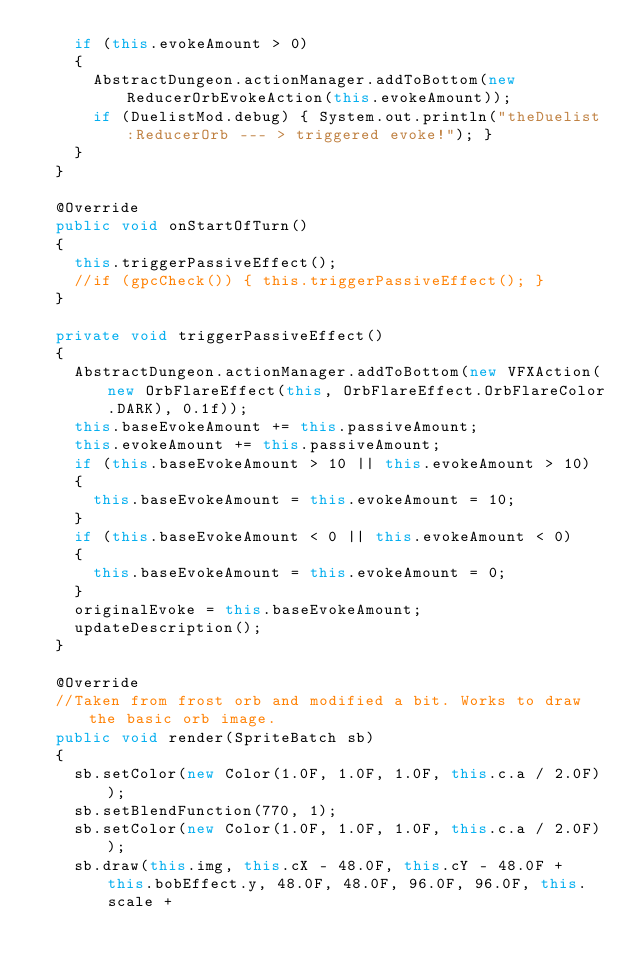Convert code to text. <code><loc_0><loc_0><loc_500><loc_500><_Java_>		if (this.evokeAmount > 0)
		{
			AbstractDungeon.actionManager.addToBottom(new ReducerOrbEvokeAction(this.evokeAmount));
			if (DuelistMod.debug) { System.out.println("theDuelist:ReducerOrb --- > triggered evoke!"); }
		}
	}

	@Override
	public void onStartOfTurn()
	{
		this.triggerPassiveEffect();
		//if (gpcCheck()) { this.triggerPassiveEffect(); }
	}

	private void triggerPassiveEffect()
	{
		AbstractDungeon.actionManager.addToBottom(new VFXAction(new OrbFlareEffect(this, OrbFlareEffect.OrbFlareColor.DARK), 0.1f));
		this.baseEvokeAmount += this.passiveAmount;
		this.evokeAmount += this.passiveAmount;
		if (this.baseEvokeAmount > 10 || this.evokeAmount > 10)
		{
			this.baseEvokeAmount = this.evokeAmount = 10;
		}
		if (this.baseEvokeAmount < 0 || this.evokeAmount < 0)
		{
			this.baseEvokeAmount = this.evokeAmount = 0;
		}
		originalEvoke = this.baseEvokeAmount;		
		updateDescription();
	}

	@Override
	//Taken from frost orb and modified a bit. Works to draw the basic orb image.
	public void render(SpriteBatch sb) 
	{
		sb.setColor(new Color(1.0F, 1.0F, 1.0F, this.c.a / 2.0F));
		sb.setBlendFunction(770, 1);
		sb.setColor(new Color(1.0F, 1.0F, 1.0F, this.c.a / 2.0F));
		sb.draw(this.img, this.cX - 48.0F, this.cY - 48.0F + this.bobEffect.y, 48.0F, 48.0F, 96.0F, 96.0F, this.scale + </code> 